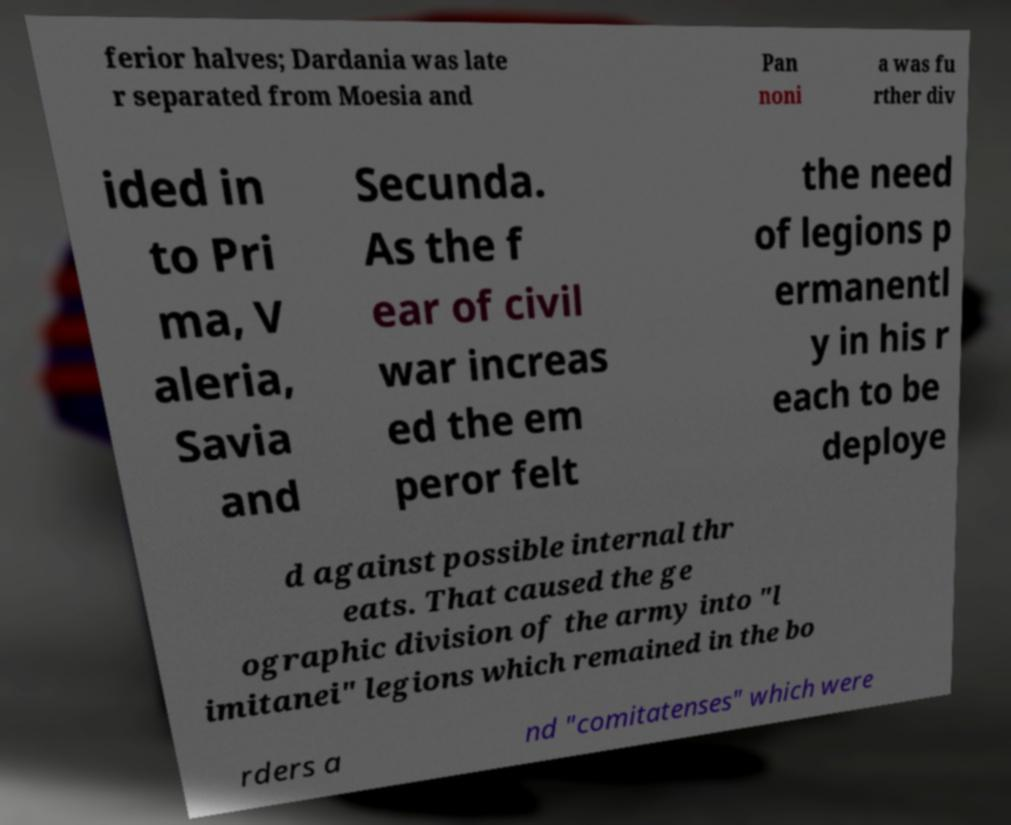Please read and relay the text visible in this image. What does it say? ferior halves; Dardania was late r separated from Moesia and Pan noni a was fu rther div ided in to Pri ma, V aleria, Savia and Secunda. As the f ear of civil war increas ed the em peror felt the need of legions p ermanentl y in his r each to be deploye d against possible internal thr eats. That caused the ge ographic division of the army into "l imitanei" legions which remained in the bo rders a nd "comitatenses" which were 